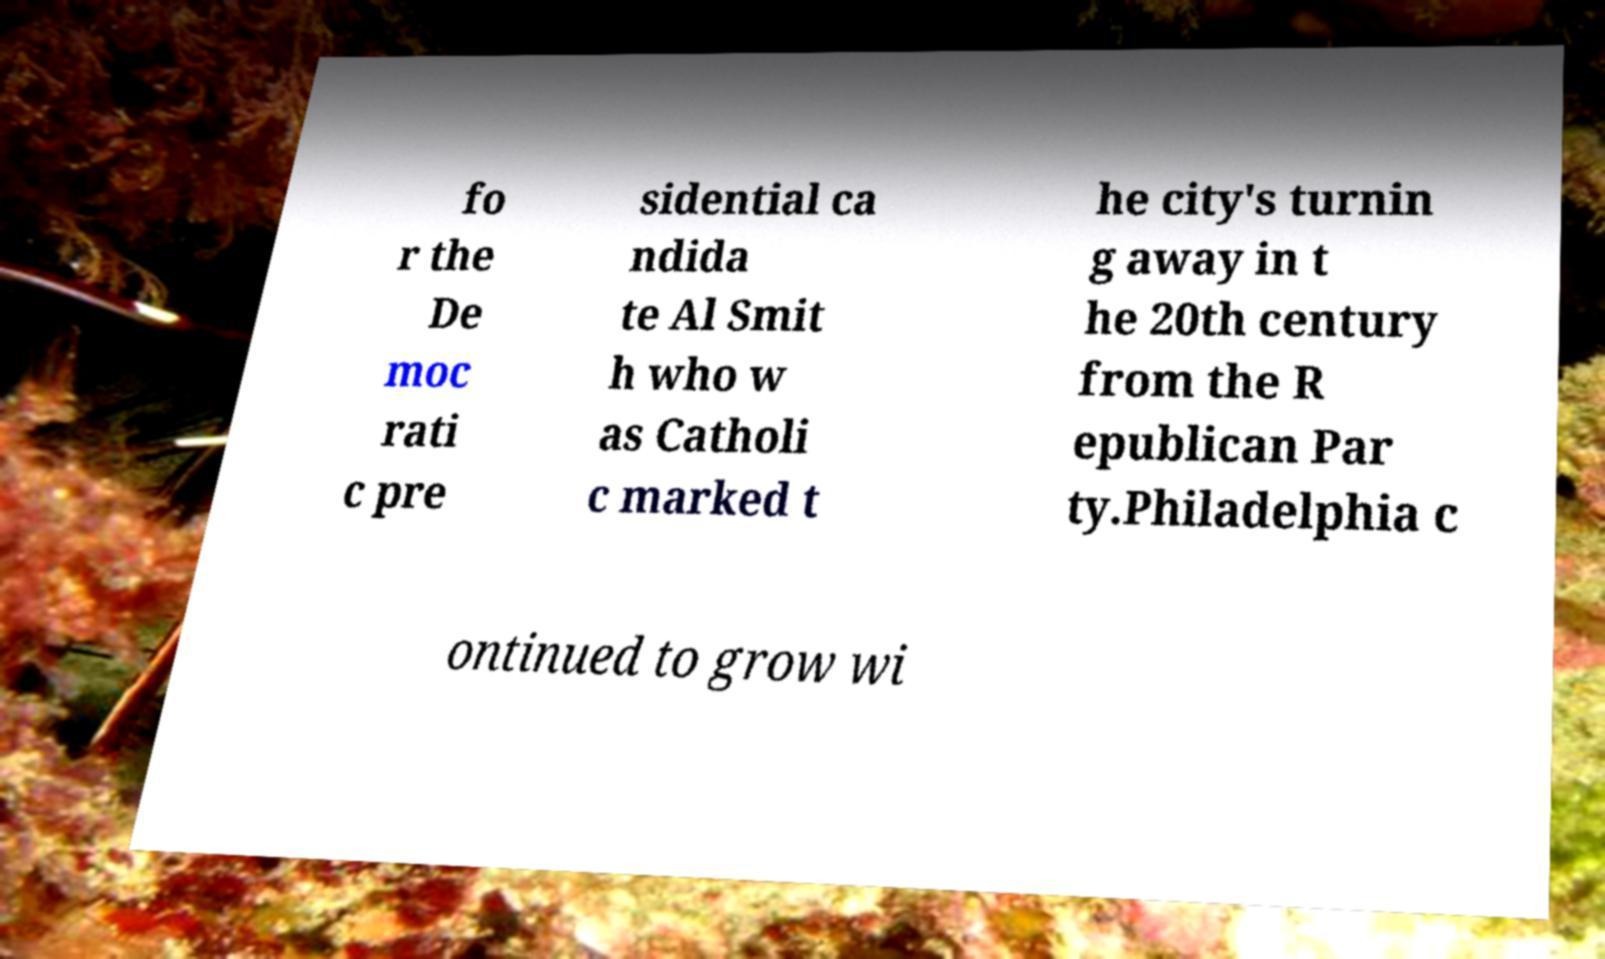Please identify and transcribe the text found in this image. fo r the De moc rati c pre sidential ca ndida te Al Smit h who w as Catholi c marked t he city's turnin g away in t he 20th century from the R epublican Par ty.Philadelphia c ontinued to grow wi 